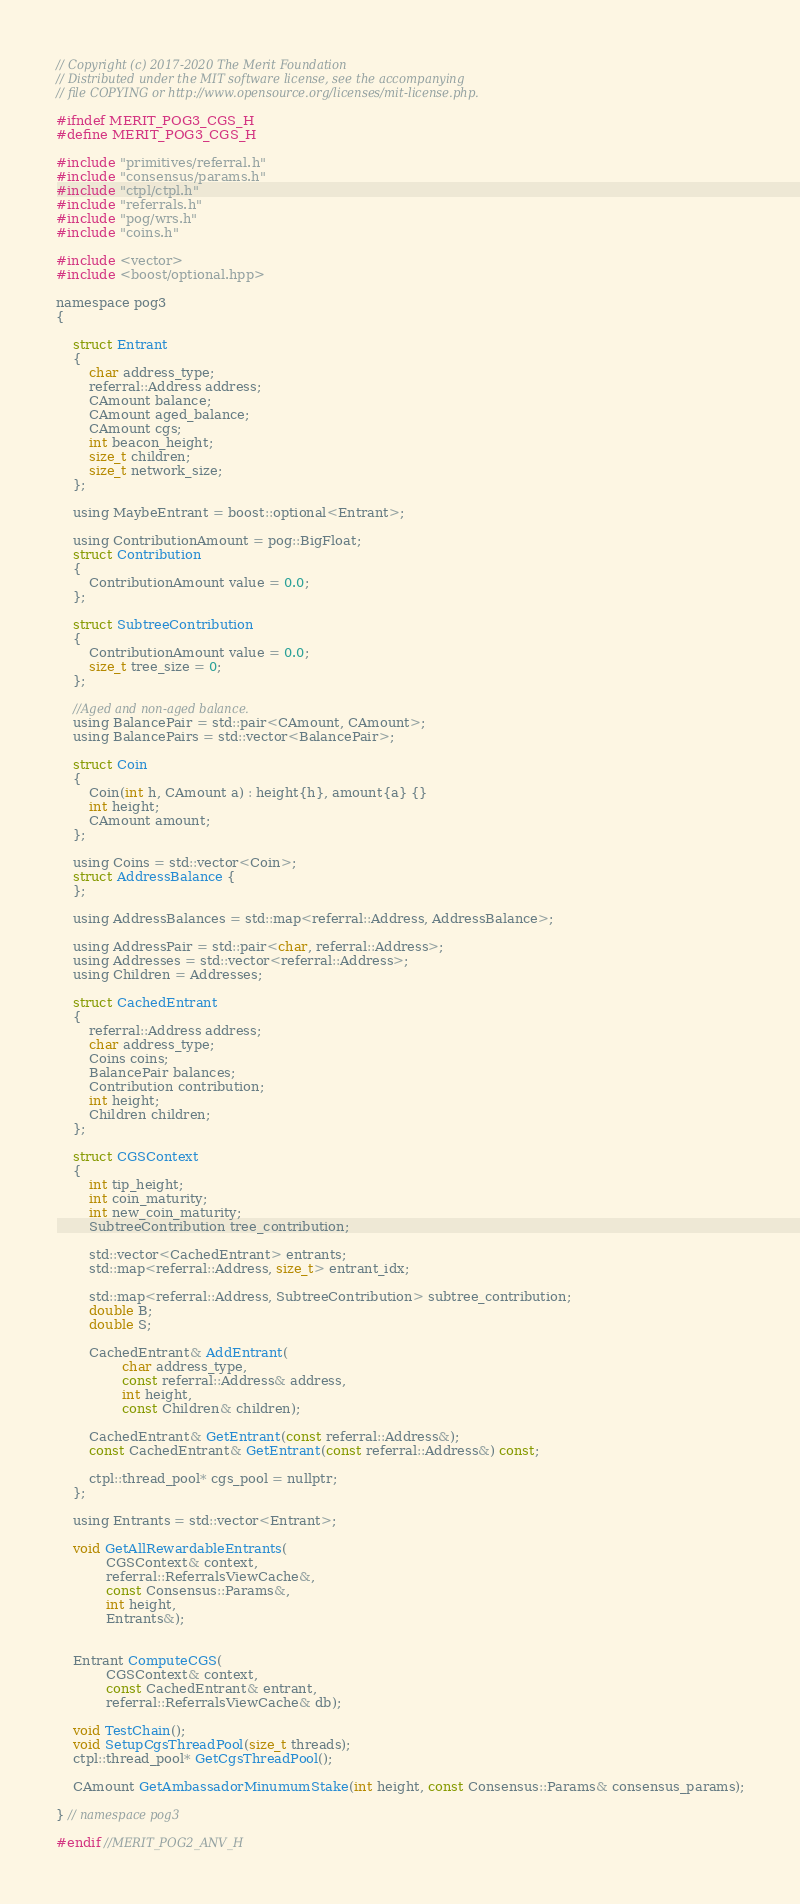<code> <loc_0><loc_0><loc_500><loc_500><_C_>// Copyright (c) 2017-2020 The Merit Foundation
// Distributed under the MIT software license, see the accompanying
// file COPYING or http://www.opensource.org/licenses/mit-license.php.

#ifndef MERIT_POG3_CGS_H
#define MERIT_POG3_CGS_H

#include "primitives/referral.h"
#include "consensus/params.h"
#include "ctpl/ctpl.h"
#include "referrals.h"
#include "pog/wrs.h"
#include "coins.h"

#include <vector>
#include <boost/optional.hpp>

namespace pog3
{

    struct Entrant
    {
        char address_type;
        referral::Address address;
        CAmount balance;
        CAmount aged_balance;
        CAmount cgs;
        int beacon_height;
        size_t children;
        size_t network_size;
    };

    using MaybeEntrant = boost::optional<Entrant>;

    using ContributionAmount = pog::BigFloat;
    struct Contribution
    {
        ContributionAmount value = 0.0;
    };

    struct SubtreeContribution
    {
        ContributionAmount value = 0.0;
        size_t tree_size = 0;
    };

    //Aged and non-aged balance.
    using BalancePair = std::pair<CAmount, CAmount>;
    using BalancePairs = std::vector<BalancePair>;

    struct Coin
    {
        Coin(int h, CAmount a) : height{h}, amount{a} {}
        int height;
        CAmount amount;
    };

    using Coins = std::vector<Coin>;
    struct AddressBalance {
    };

    using AddressBalances = std::map<referral::Address, AddressBalance>;

    using AddressPair = std::pair<char, referral::Address>;
    using Addresses = std::vector<referral::Address>;
    using Children = Addresses;

    struct CachedEntrant
    {
        referral::Address address;
        char address_type;
        Coins coins;
        BalancePair balances;
        Contribution contribution;
        int height;
        Children children;
    };

    struct CGSContext
    {
        int tip_height;
        int coin_maturity;
        int new_coin_maturity;
        SubtreeContribution tree_contribution; 

        std::vector<CachedEntrant> entrants;
        std::map<referral::Address, size_t> entrant_idx;

        std::map<referral::Address, SubtreeContribution> subtree_contribution;
        double B;
        double S;

        CachedEntrant& AddEntrant(
                char address_type,
                const referral::Address& address,
                int height,
                const Children& children);

        CachedEntrant& GetEntrant(const referral::Address&);
        const CachedEntrant& GetEntrant(const referral::Address&) const;

        ctpl::thread_pool* cgs_pool = nullptr;
    };

    using Entrants = std::vector<Entrant>;

    void GetAllRewardableEntrants(
            CGSContext& context,
            referral::ReferralsViewCache&,
            const Consensus::Params&,
            int height,
            Entrants&);


    Entrant ComputeCGS(
            CGSContext& context,
            const CachedEntrant& entrant,
            referral::ReferralsViewCache& db);

    void TestChain();
    void SetupCgsThreadPool(size_t threads);
    ctpl::thread_pool* GetCgsThreadPool();

    CAmount GetAmbassadorMinumumStake(int height, const Consensus::Params& consensus_params);

} // namespace pog3

#endif //MERIT_POG2_ANV_H
</code> 